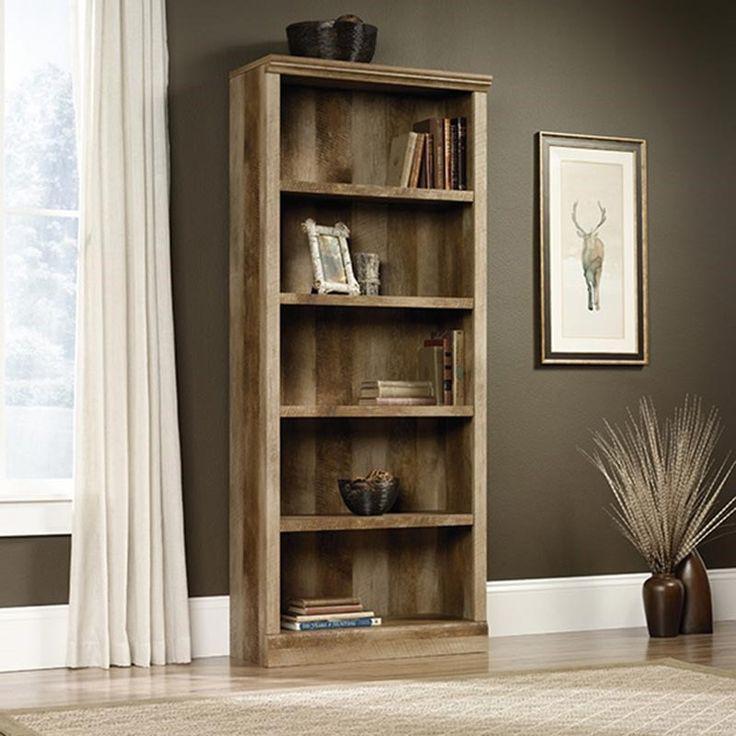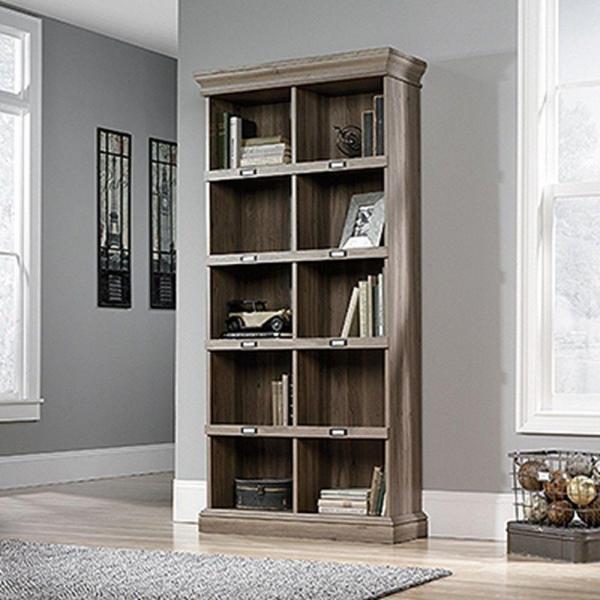The first image is the image on the left, the second image is the image on the right. Analyze the images presented: Is the assertion "There is a pot of plant with white flowers on top of a shelf." valid? Answer yes or no. No. 